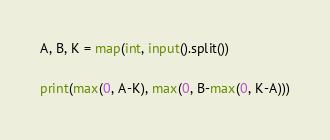<code> <loc_0><loc_0><loc_500><loc_500><_Python_>A, B, K = map(int, input().split())

print(max(0, A-K), max(0, B-max(0, K-A)))</code> 